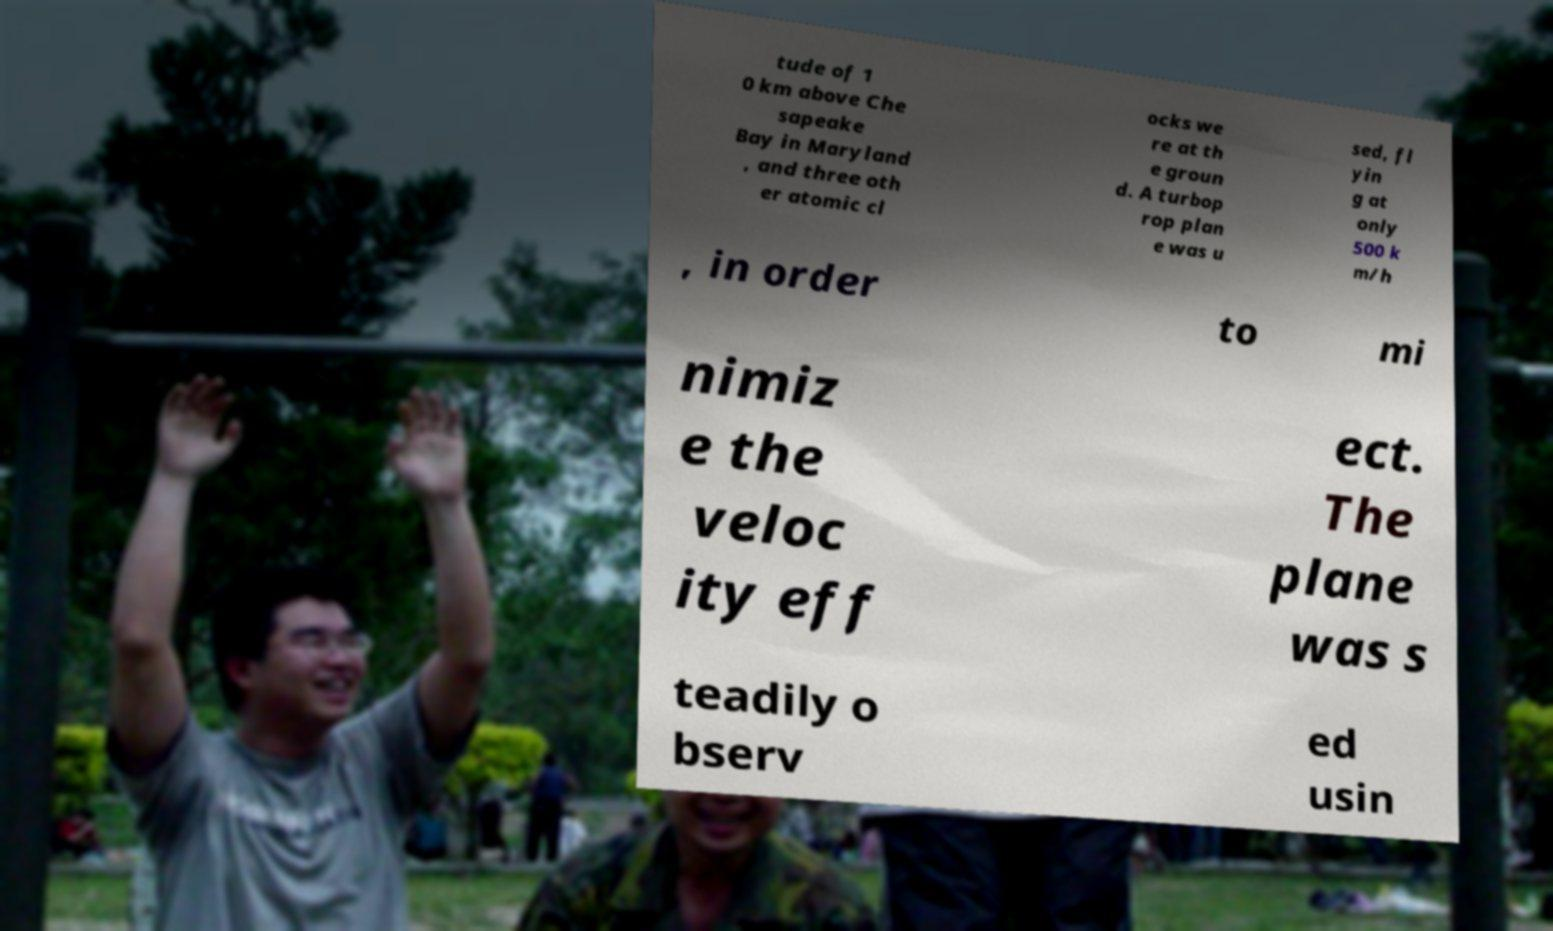Could you extract and type out the text from this image? tude of 1 0 km above Che sapeake Bay in Maryland , and three oth er atomic cl ocks we re at th e groun d. A turbop rop plan e was u sed, fl yin g at only 500 k m/h , in order to mi nimiz e the veloc ity eff ect. The plane was s teadily o bserv ed usin 